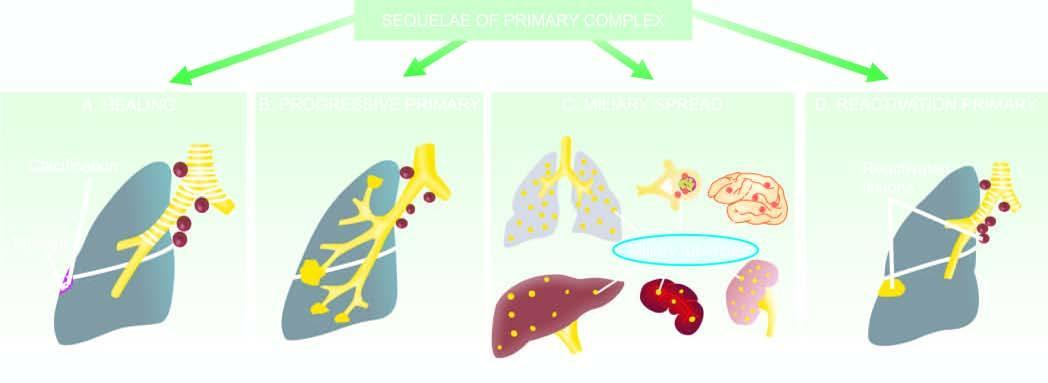did these cells spread to lungs, liver, spleen, kidneys and brain?
Answer the question using a single word or phrase. No 